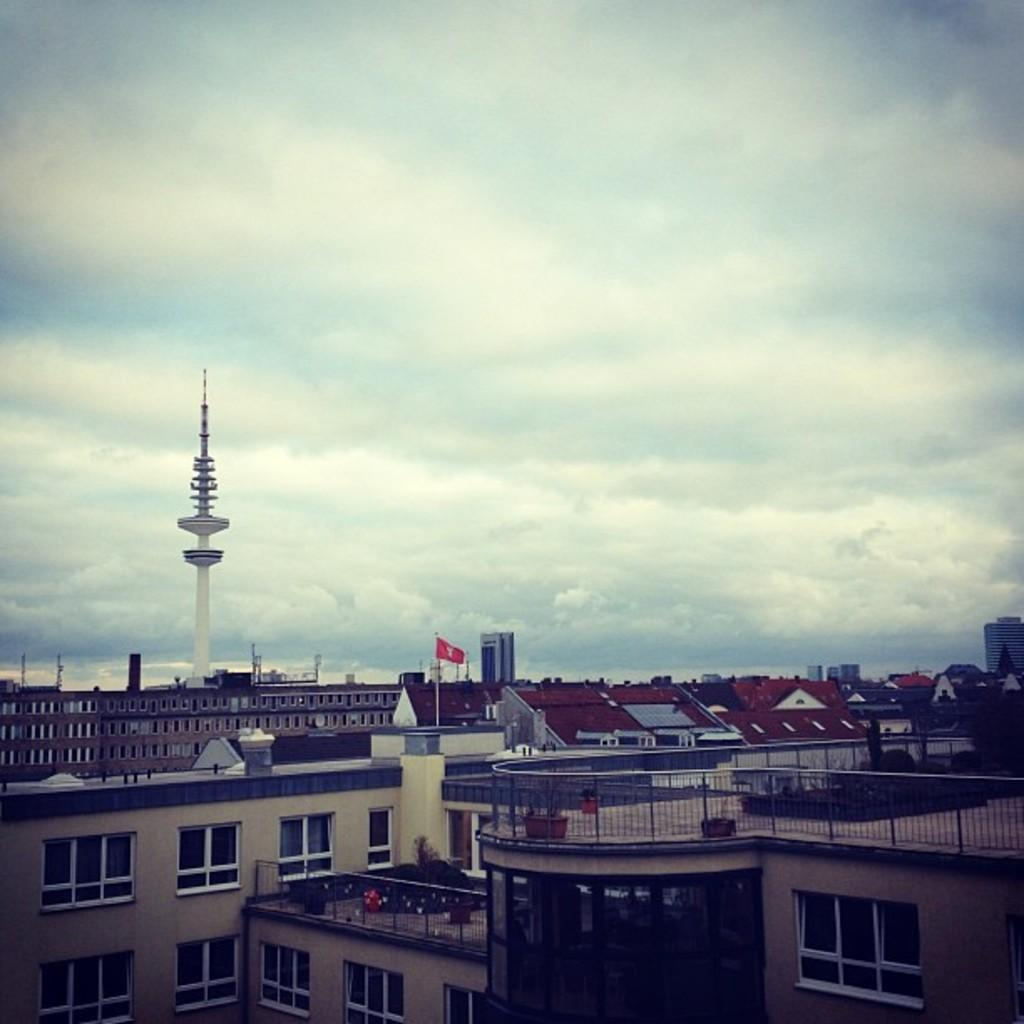What type of structures are present in the image? There are houses and buildings in the image. What feature do the houses and buildings have? The houses and buildings have windows. What additional structure can be seen in the image? There is a tower in the image. What is attached to the tower? There is a flag in the image. What is visible in the background of the image? The sky is visible in the image. What type of vest is being worn by the tower in the image? There is no vest present in the image, as the tower is an inanimate structure. What type of spark can be seen coming from the flag in the image? There is no spark present in the image; the flag is simply attached to the tower. 